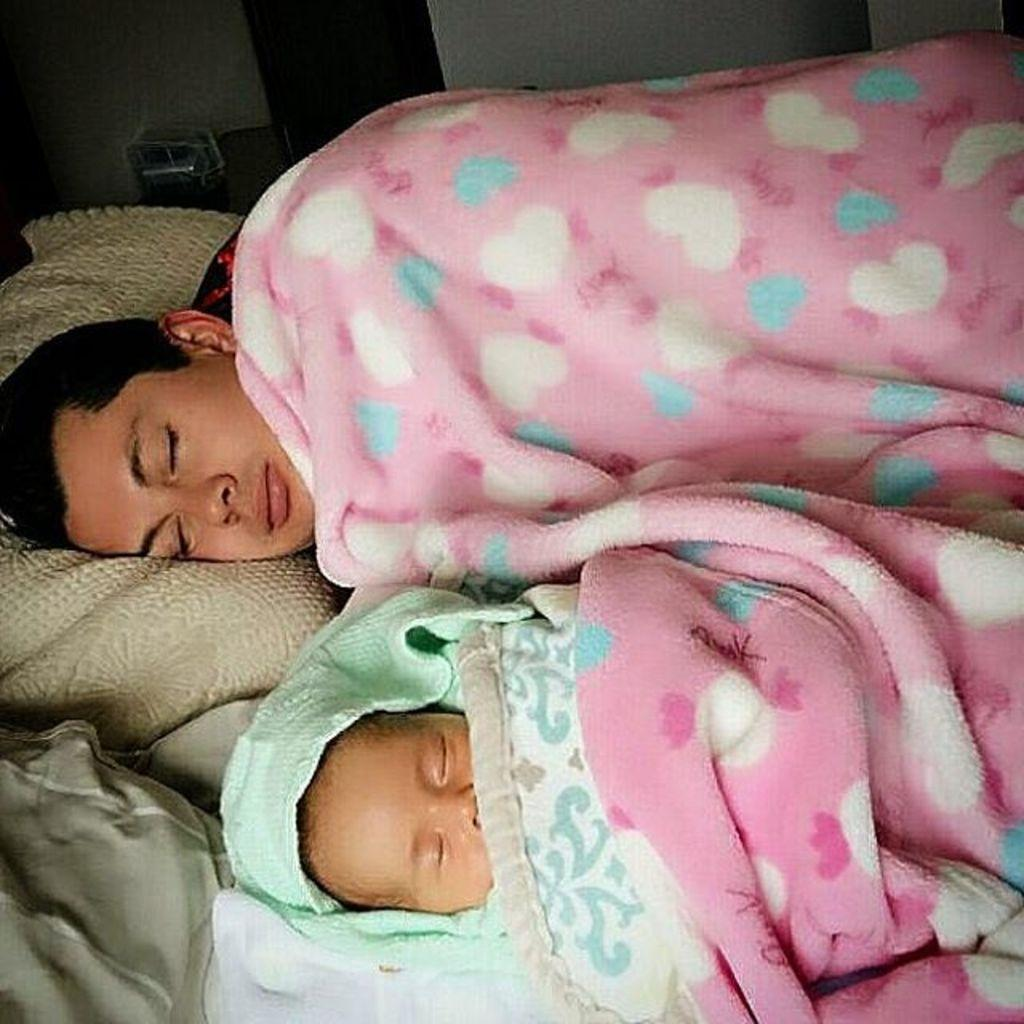Who is present in the image? There is a man and a baby in the image. What are the man and the baby doing in the image? Both the man and the baby are sleeping on a bed in the image. What items can be seen on the bed? There are blankets and pillows on the bed in the image. What is visible in the background of the image? There is a wall in the background of the image. What type of boot is hanging on the wall in the image? There is no boot present in the image; only a man, a baby, a bed, blankets, pillows, and a wall are visible. 